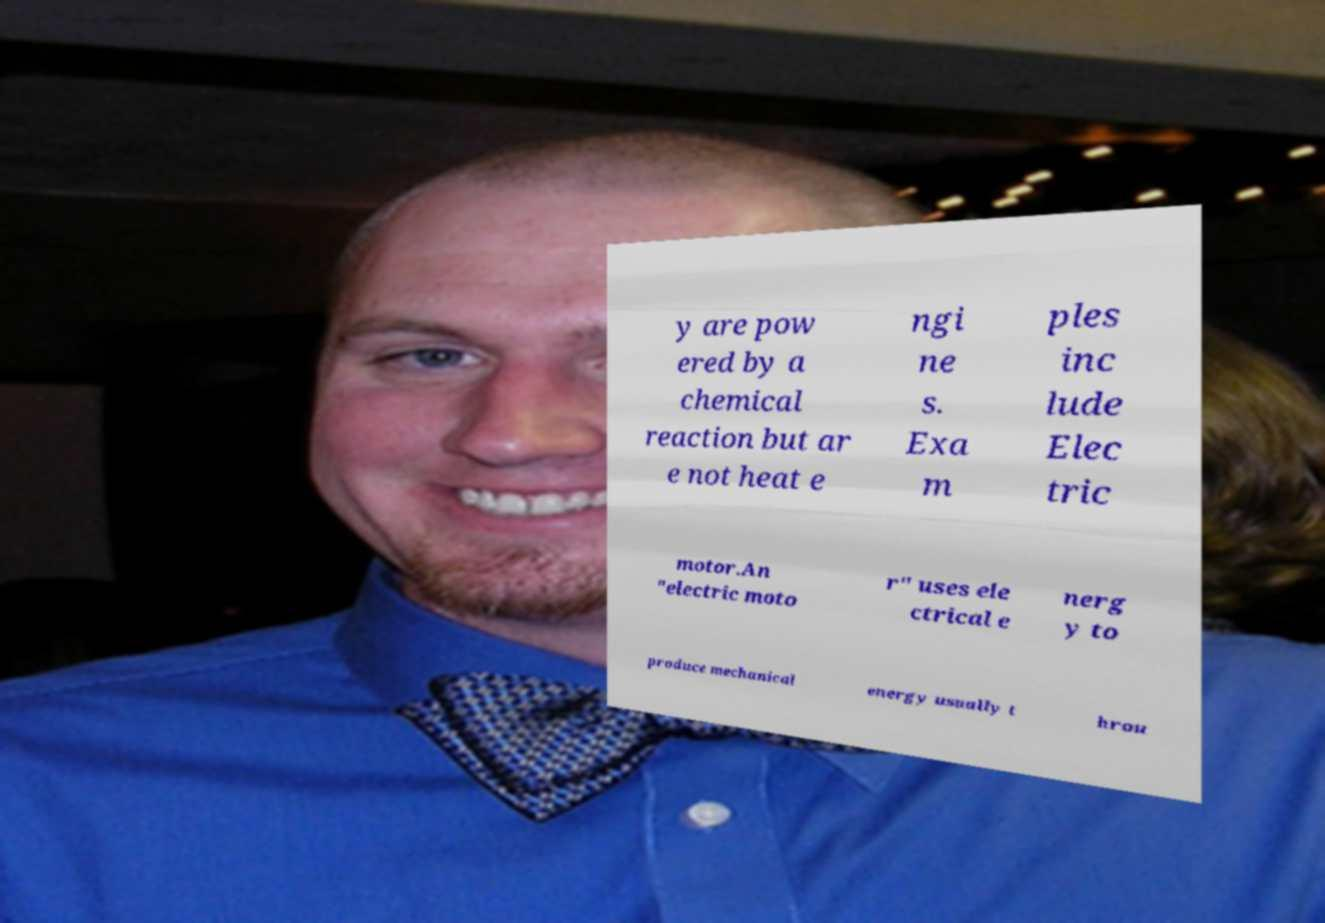For documentation purposes, I need the text within this image transcribed. Could you provide that? y are pow ered by a chemical reaction but ar e not heat e ngi ne s. Exa m ples inc lude Elec tric motor.An "electric moto r" uses ele ctrical e nerg y to produce mechanical energy usually t hrou 